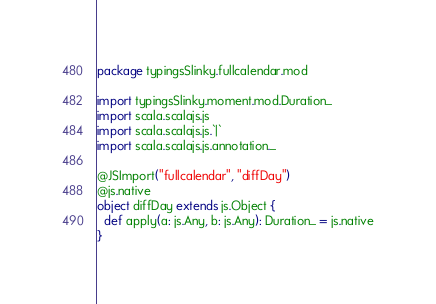<code> <loc_0><loc_0><loc_500><loc_500><_Scala_>package typingsSlinky.fullcalendar.mod

import typingsSlinky.moment.mod.Duration_
import scala.scalajs.js
import scala.scalajs.js.`|`
import scala.scalajs.js.annotation._

@JSImport("fullcalendar", "diffDay")
@js.native
object diffDay extends js.Object {
  def apply(a: js.Any, b: js.Any): Duration_ = js.native
}

</code> 